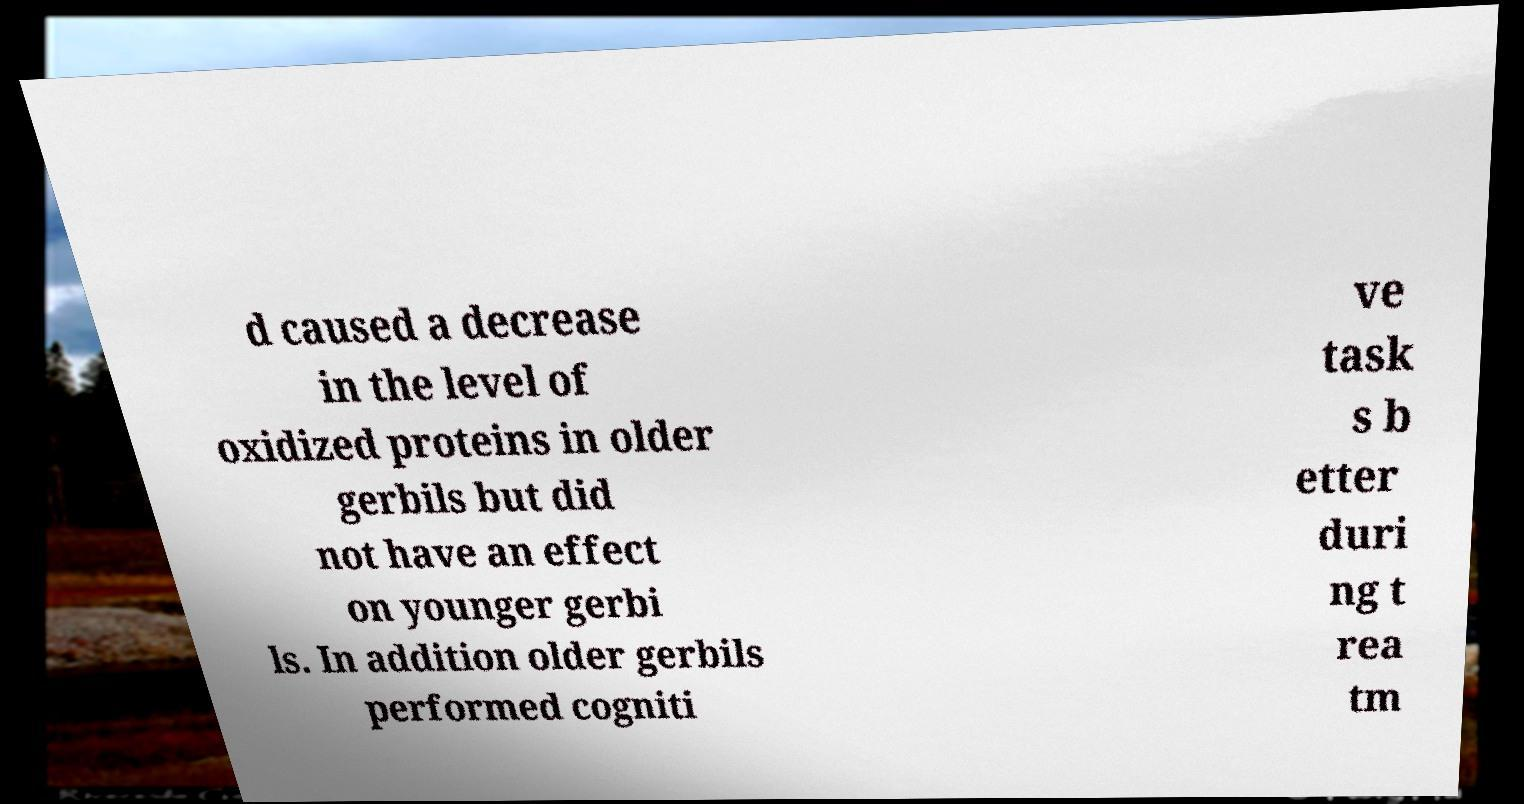Please identify and transcribe the text found in this image. d caused a decrease in the level of oxidized proteins in older gerbils but did not have an effect on younger gerbi ls. In addition older gerbils performed cogniti ve task s b etter duri ng t rea tm 